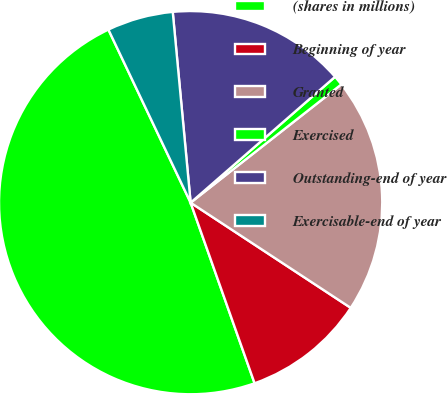Convert chart. <chart><loc_0><loc_0><loc_500><loc_500><pie_chart><fcel>(shares in millions)<fcel>Beginning of year<fcel>Granted<fcel>Exercised<fcel>Outstanding-end of year<fcel>Exercisable-end of year<nl><fcel>48.36%<fcel>10.33%<fcel>19.84%<fcel>0.82%<fcel>15.08%<fcel>5.57%<nl></chart> 